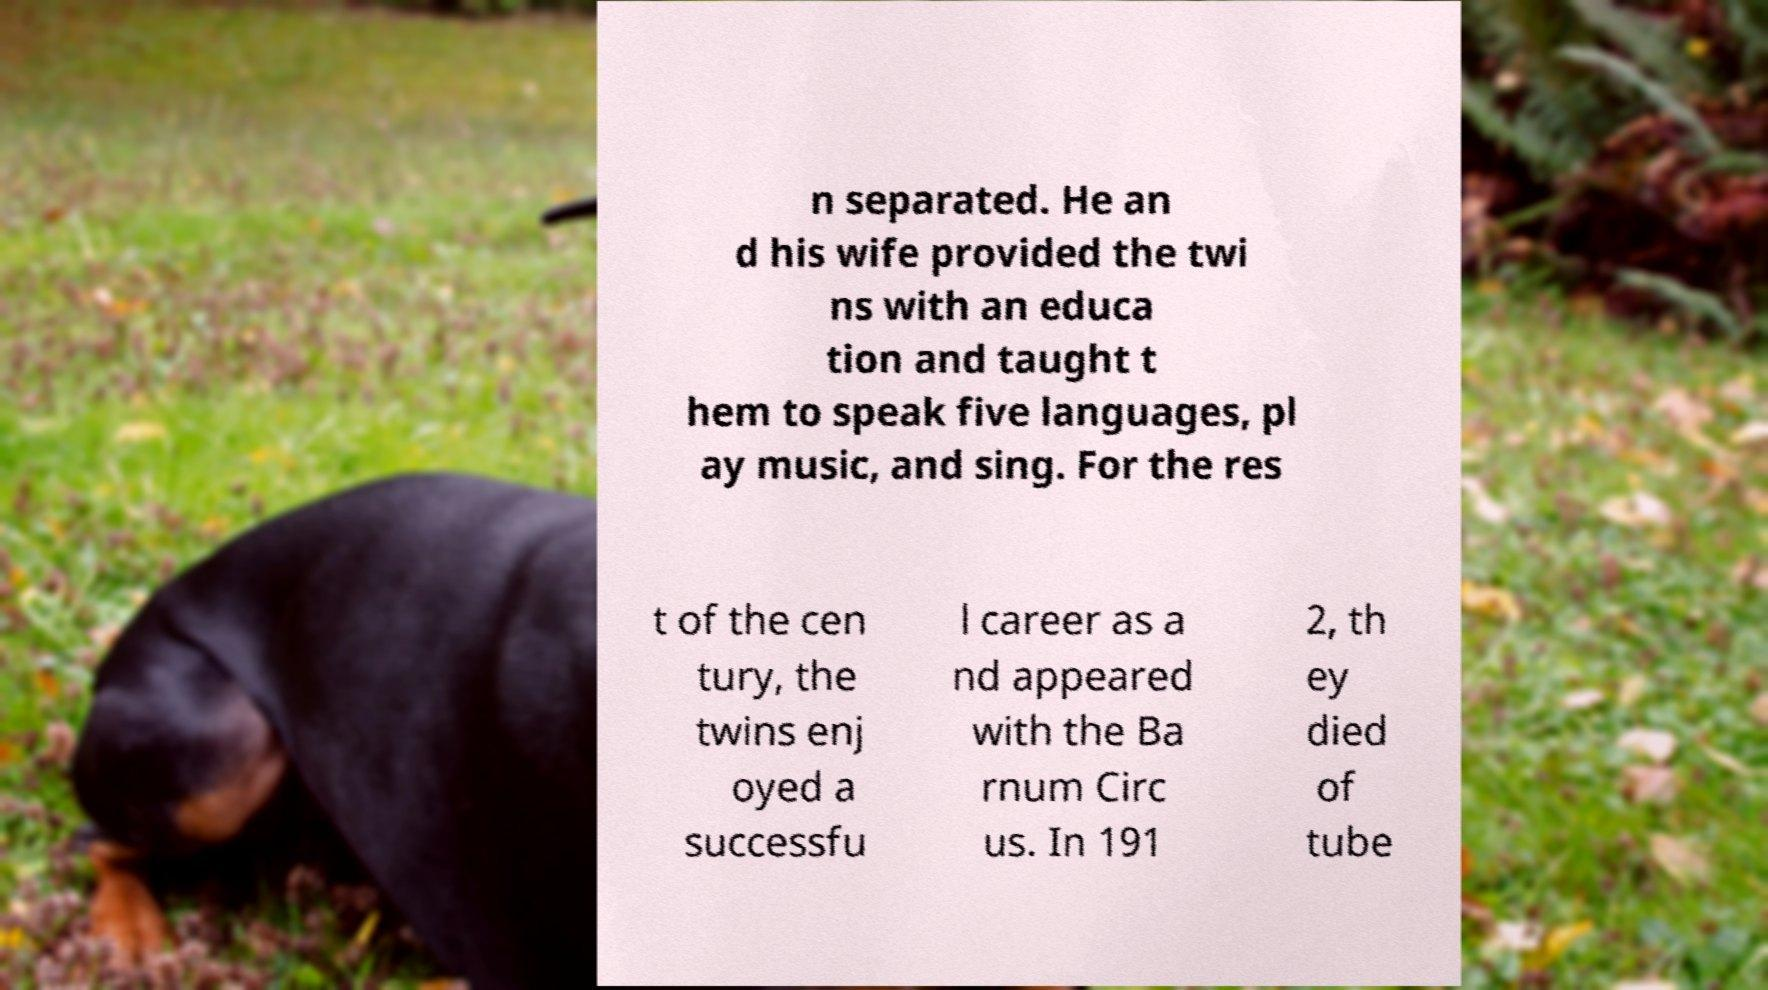I need the written content from this picture converted into text. Can you do that? n separated. He an d his wife provided the twi ns with an educa tion and taught t hem to speak five languages, pl ay music, and sing. For the res t of the cen tury, the twins enj oyed a successfu l career as a nd appeared with the Ba rnum Circ us. In 191 2, th ey died of tube 